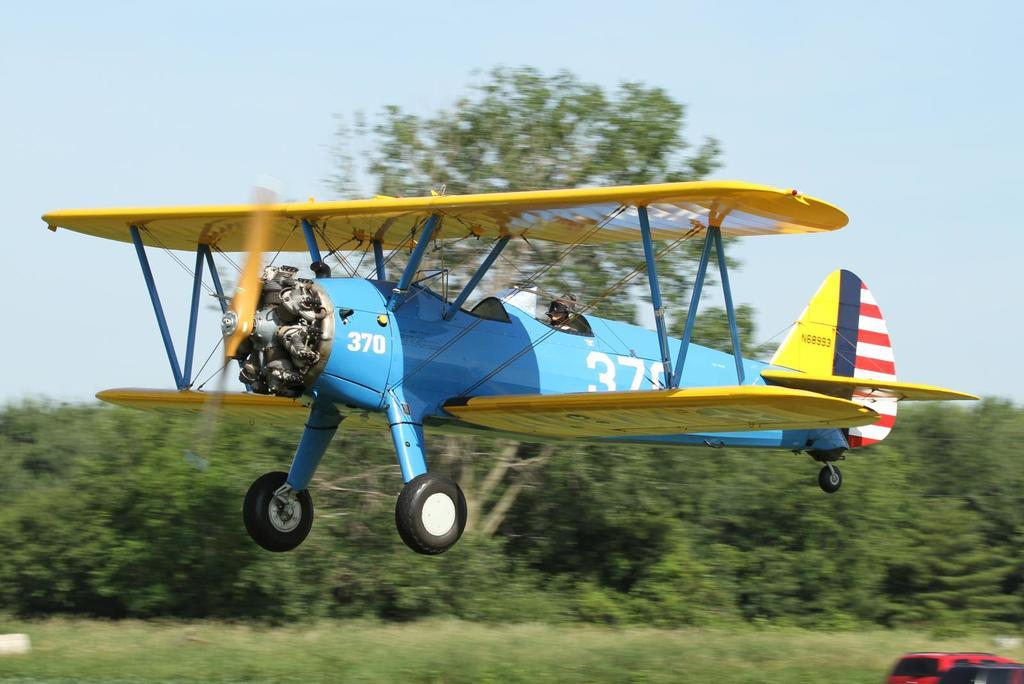<image>
Provide a brief description of the given image. a small single engine blue plane numbered 370 either landing or taking off. 